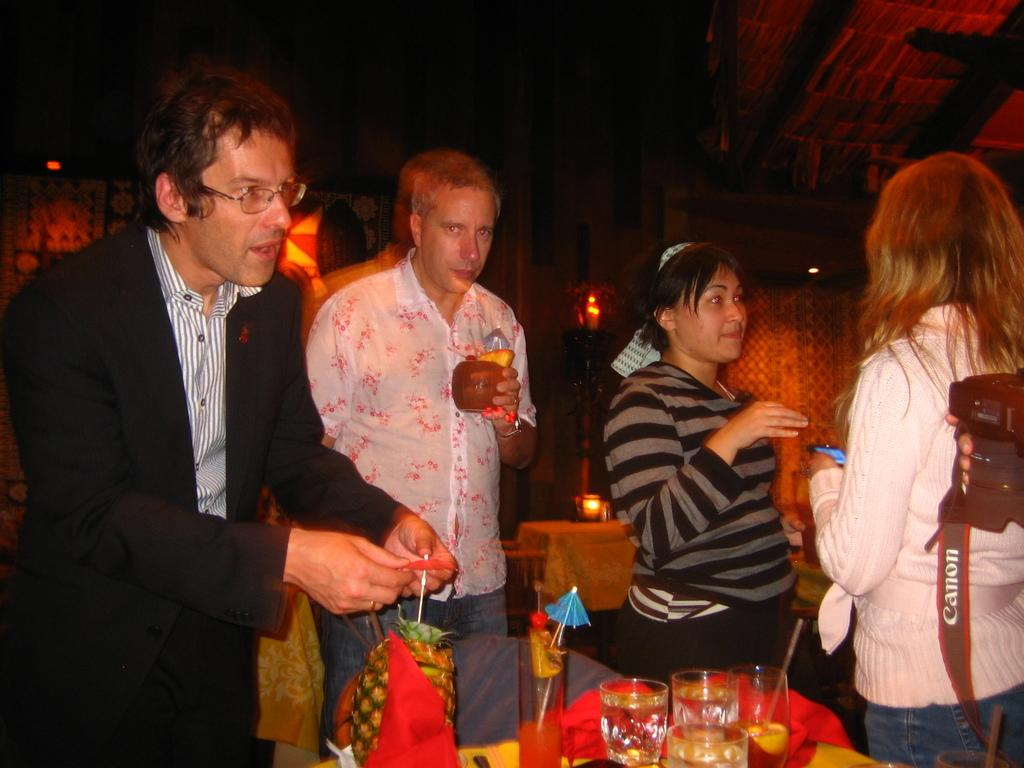What can be seen in the image involving people? There are people standing in the image. What objects are present in the image that people might use? There are glasses and umbrellas in the image. What type of fruit is visible in the image? There is a pineapple in the image. What items are on a table in the image? There are objects on a table in the image. What furniture can be seen in the background of the image? There are chairs and a table in the background of the image. What type of lighting is present in the background of the image? There are lights in the background of the image. What is the value of the dime on the table in the image? There is no mention of a dime in the image, so it cannot be determined. How does love play a role in the image? The image does not depict any emotions or relationships, so it is impossible to determine the role of love in the image. 